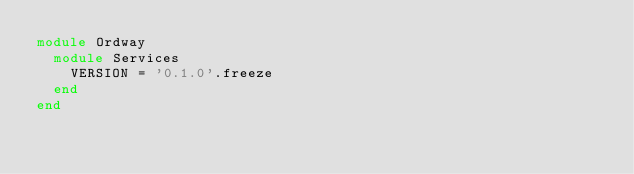<code> <loc_0><loc_0><loc_500><loc_500><_Ruby_>module Ordway
  module Services
    VERSION = '0.1.0'.freeze
  end
end
</code> 